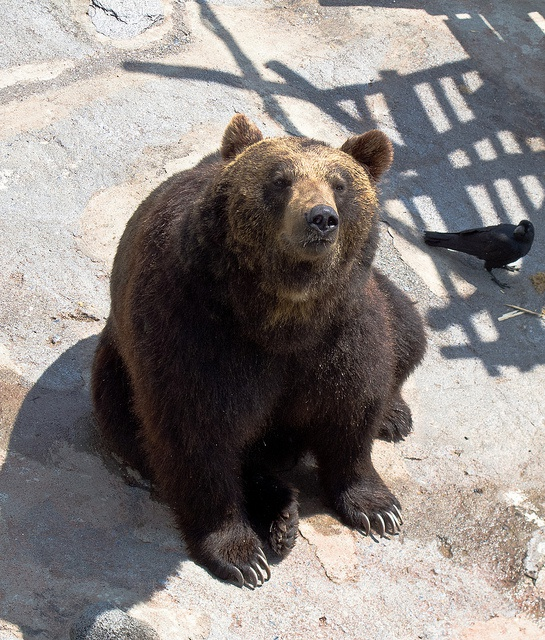Describe the objects in this image and their specific colors. I can see bear in lightgray, black, gray, and maroon tones and bird in lightgray, black, and gray tones in this image. 